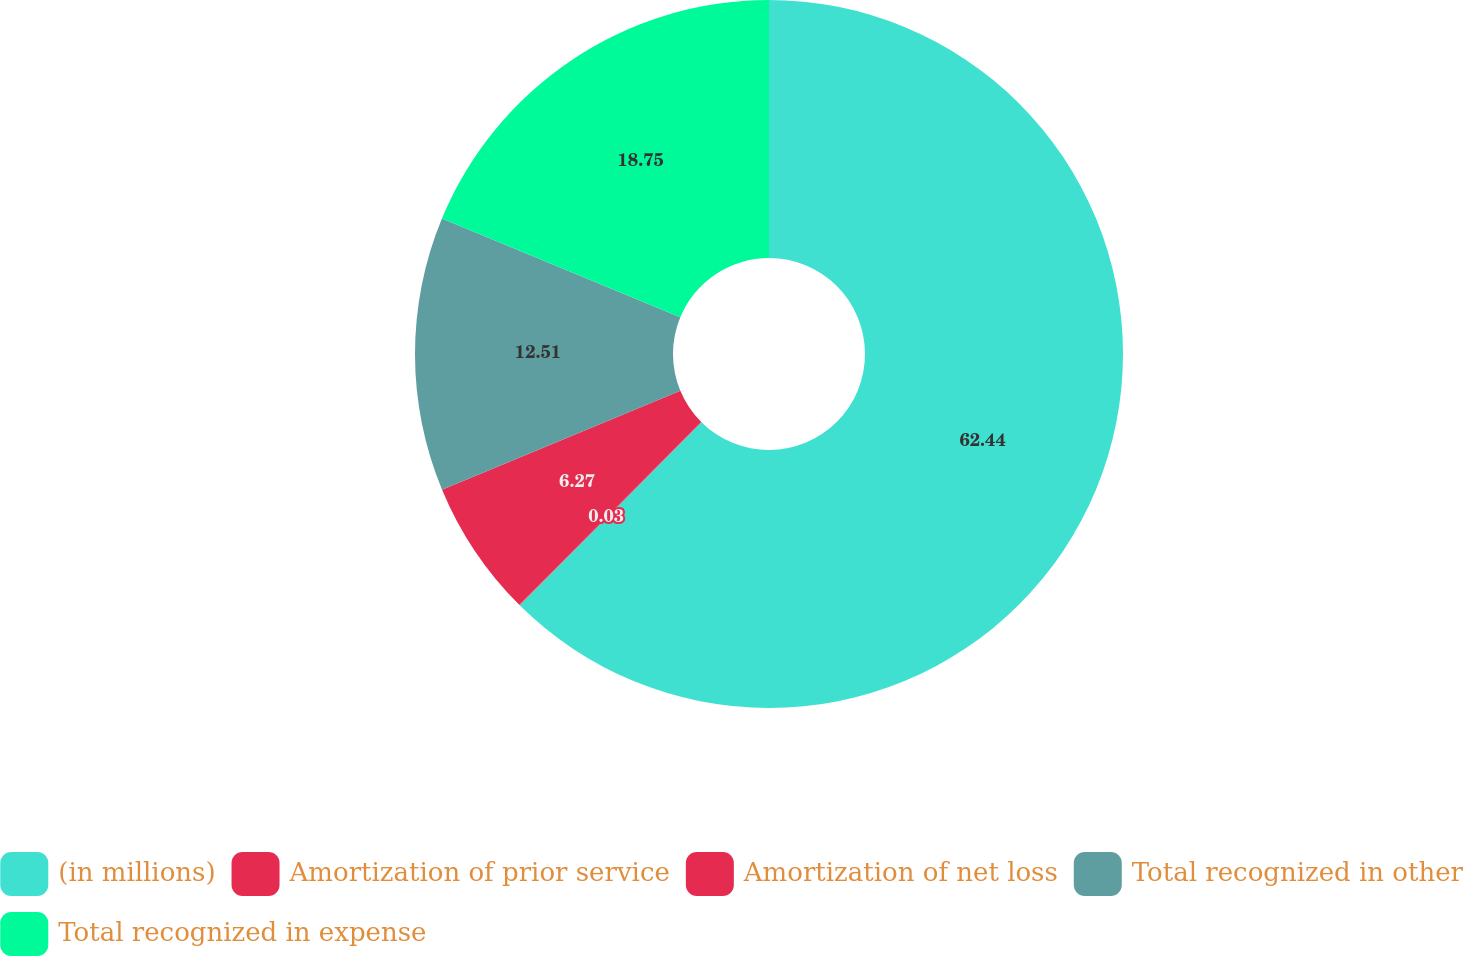Convert chart to OTSL. <chart><loc_0><loc_0><loc_500><loc_500><pie_chart><fcel>(in millions)<fcel>Amortization of prior service<fcel>Amortization of net loss<fcel>Total recognized in other<fcel>Total recognized in expense<nl><fcel>62.43%<fcel>0.03%<fcel>6.27%<fcel>12.51%<fcel>18.75%<nl></chart> 